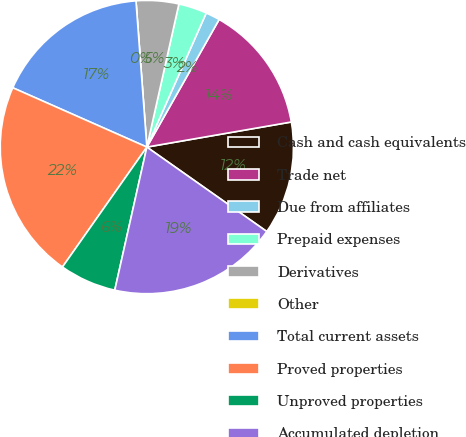Convert chart. <chart><loc_0><loc_0><loc_500><loc_500><pie_chart><fcel>Cash and cash equivalents<fcel>Trade net<fcel>Due from affiliates<fcel>Prepaid expenses<fcel>Derivatives<fcel>Other<fcel>Total current assets<fcel>Proved properties<fcel>Unproved properties<fcel>Accumulated depletion<nl><fcel>12.5%<fcel>14.06%<fcel>1.57%<fcel>3.13%<fcel>4.69%<fcel>0.0%<fcel>17.19%<fcel>21.87%<fcel>6.25%<fcel>18.75%<nl></chart> 